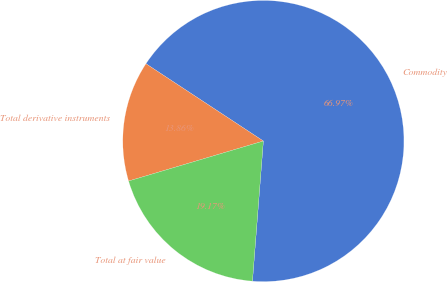<chart> <loc_0><loc_0><loc_500><loc_500><pie_chart><fcel>Commodity<fcel>Total derivative instruments<fcel>Total at fair value<nl><fcel>66.97%<fcel>13.86%<fcel>19.17%<nl></chart> 